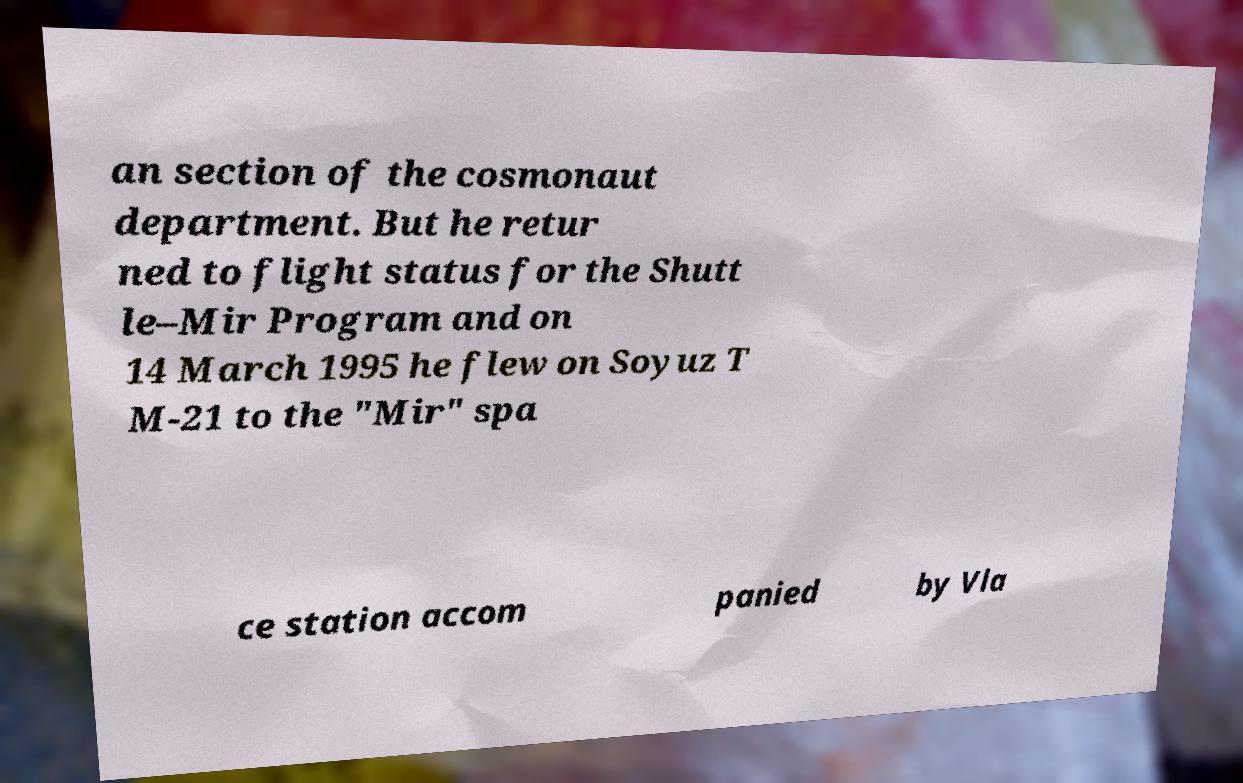Can you accurately transcribe the text from the provided image for me? an section of the cosmonaut department. But he retur ned to flight status for the Shutt le–Mir Program and on 14 March 1995 he flew on Soyuz T M-21 to the "Mir" spa ce station accom panied by Vla 